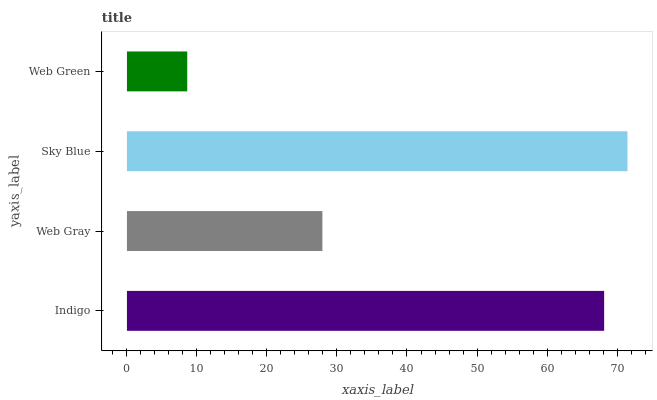Is Web Green the minimum?
Answer yes or no. Yes. Is Sky Blue the maximum?
Answer yes or no. Yes. Is Web Gray the minimum?
Answer yes or no. No. Is Web Gray the maximum?
Answer yes or no. No. Is Indigo greater than Web Gray?
Answer yes or no. Yes. Is Web Gray less than Indigo?
Answer yes or no. Yes. Is Web Gray greater than Indigo?
Answer yes or no. No. Is Indigo less than Web Gray?
Answer yes or no. No. Is Indigo the high median?
Answer yes or no. Yes. Is Web Gray the low median?
Answer yes or no. Yes. Is Sky Blue the high median?
Answer yes or no. No. Is Indigo the low median?
Answer yes or no. No. 